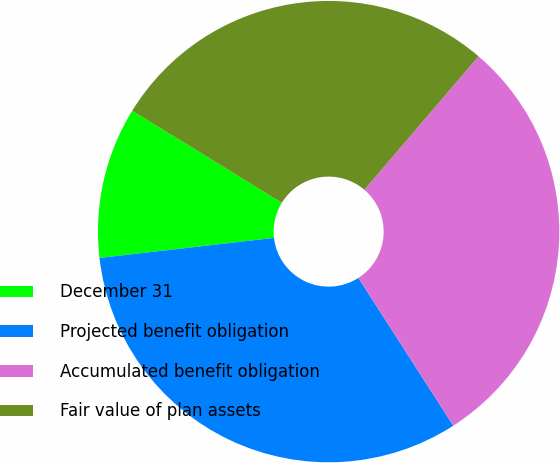<chart> <loc_0><loc_0><loc_500><loc_500><pie_chart><fcel>December 31<fcel>Projected benefit obligation<fcel>Accumulated benefit obligation<fcel>Fair value of plan assets<nl><fcel>10.6%<fcel>32.26%<fcel>29.65%<fcel>27.48%<nl></chart> 